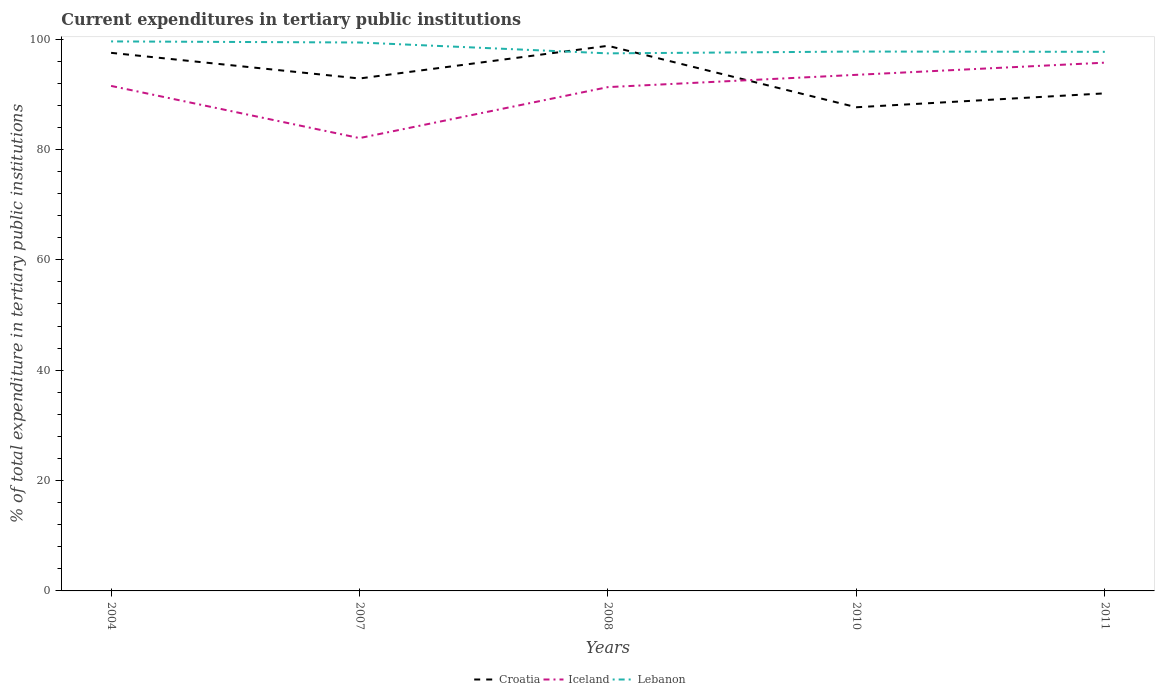Is the number of lines equal to the number of legend labels?
Your answer should be compact. Yes. Across all years, what is the maximum current expenditures in tertiary public institutions in Lebanon?
Offer a terse response. 97.41. What is the total current expenditures in tertiary public institutions in Lebanon in the graph?
Provide a succinct answer. 0.2. What is the difference between the highest and the second highest current expenditures in tertiary public institutions in Iceland?
Offer a terse response. 13.67. Is the current expenditures in tertiary public institutions in Lebanon strictly greater than the current expenditures in tertiary public institutions in Iceland over the years?
Your answer should be very brief. No. How many lines are there?
Provide a short and direct response. 3. What is the difference between two consecutive major ticks on the Y-axis?
Offer a very short reply. 20. Does the graph contain grids?
Make the answer very short. No. How many legend labels are there?
Provide a short and direct response. 3. What is the title of the graph?
Provide a succinct answer. Current expenditures in tertiary public institutions. Does "Spain" appear as one of the legend labels in the graph?
Make the answer very short. No. What is the label or title of the X-axis?
Ensure brevity in your answer.  Years. What is the label or title of the Y-axis?
Your response must be concise. % of total expenditure in tertiary public institutions. What is the % of total expenditure in tertiary public institutions of Croatia in 2004?
Your answer should be compact. 97.5. What is the % of total expenditure in tertiary public institutions of Iceland in 2004?
Keep it short and to the point. 91.51. What is the % of total expenditure in tertiary public institutions in Lebanon in 2004?
Make the answer very short. 99.57. What is the % of total expenditure in tertiary public institutions in Croatia in 2007?
Ensure brevity in your answer.  92.85. What is the % of total expenditure in tertiary public institutions of Iceland in 2007?
Give a very brief answer. 82.05. What is the % of total expenditure in tertiary public institutions in Lebanon in 2007?
Provide a succinct answer. 99.38. What is the % of total expenditure in tertiary public institutions in Croatia in 2008?
Keep it short and to the point. 98.78. What is the % of total expenditure in tertiary public institutions in Iceland in 2008?
Offer a terse response. 91.29. What is the % of total expenditure in tertiary public institutions in Lebanon in 2008?
Keep it short and to the point. 97.41. What is the % of total expenditure in tertiary public institutions of Croatia in 2010?
Make the answer very short. 87.64. What is the % of total expenditure in tertiary public institutions in Iceland in 2010?
Make the answer very short. 93.52. What is the % of total expenditure in tertiary public institutions in Lebanon in 2010?
Your answer should be very brief. 97.74. What is the % of total expenditure in tertiary public institutions in Croatia in 2011?
Your answer should be very brief. 90.16. What is the % of total expenditure in tertiary public institutions in Iceland in 2011?
Your answer should be compact. 95.72. What is the % of total expenditure in tertiary public institutions in Lebanon in 2011?
Your answer should be very brief. 97.69. Across all years, what is the maximum % of total expenditure in tertiary public institutions in Croatia?
Ensure brevity in your answer.  98.78. Across all years, what is the maximum % of total expenditure in tertiary public institutions of Iceland?
Keep it short and to the point. 95.72. Across all years, what is the maximum % of total expenditure in tertiary public institutions of Lebanon?
Keep it short and to the point. 99.57. Across all years, what is the minimum % of total expenditure in tertiary public institutions in Croatia?
Keep it short and to the point. 87.64. Across all years, what is the minimum % of total expenditure in tertiary public institutions of Iceland?
Make the answer very short. 82.05. Across all years, what is the minimum % of total expenditure in tertiary public institutions in Lebanon?
Your answer should be compact. 97.41. What is the total % of total expenditure in tertiary public institutions in Croatia in the graph?
Ensure brevity in your answer.  466.94. What is the total % of total expenditure in tertiary public institutions in Iceland in the graph?
Provide a short and direct response. 454.09. What is the total % of total expenditure in tertiary public institutions in Lebanon in the graph?
Offer a very short reply. 491.78. What is the difference between the % of total expenditure in tertiary public institutions in Croatia in 2004 and that in 2007?
Your response must be concise. 4.65. What is the difference between the % of total expenditure in tertiary public institutions of Iceland in 2004 and that in 2007?
Provide a succinct answer. 9.46. What is the difference between the % of total expenditure in tertiary public institutions of Lebanon in 2004 and that in 2007?
Offer a terse response. 0.2. What is the difference between the % of total expenditure in tertiary public institutions in Croatia in 2004 and that in 2008?
Offer a terse response. -1.27. What is the difference between the % of total expenditure in tertiary public institutions in Iceland in 2004 and that in 2008?
Make the answer very short. 0.22. What is the difference between the % of total expenditure in tertiary public institutions in Lebanon in 2004 and that in 2008?
Keep it short and to the point. 2.17. What is the difference between the % of total expenditure in tertiary public institutions in Croatia in 2004 and that in 2010?
Provide a succinct answer. 9.86. What is the difference between the % of total expenditure in tertiary public institutions in Iceland in 2004 and that in 2010?
Provide a succinct answer. -2.01. What is the difference between the % of total expenditure in tertiary public institutions in Lebanon in 2004 and that in 2010?
Make the answer very short. 1.84. What is the difference between the % of total expenditure in tertiary public institutions of Croatia in 2004 and that in 2011?
Keep it short and to the point. 7.34. What is the difference between the % of total expenditure in tertiary public institutions of Iceland in 2004 and that in 2011?
Provide a succinct answer. -4.21. What is the difference between the % of total expenditure in tertiary public institutions of Lebanon in 2004 and that in 2011?
Give a very brief answer. 1.89. What is the difference between the % of total expenditure in tertiary public institutions of Croatia in 2007 and that in 2008?
Make the answer very short. -5.92. What is the difference between the % of total expenditure in tertiary public institutions in Iceland in 2007 and that in 2008?
Offer a terse response. -9.24. What is the difference between the % of total expenditure in tertiary public institutions in Lebanon in 2007 and that in 2008?
Ensure brevity in your answer.  1.97. What is the difference between the % of total expenditure in tertiary public institutions of Croatia in 2007 and that in 2010?
Provide a short and direct response. 5.21. What is the difference between the % of total expenditure in tertiary public institutions of Iceland in 2007 and that in 2010?
Your answer should be very brief. -11.47. What is the difference between the % of total expenditure in tertiary public institutions of Lebanon in 2007 and that in 2010?
Ensure brevity in your answer.  1.64. What is the difference between the % of total expenditure in tertiary public institutions of Croatia in 2007 and that in 2011?
Keep it short and to the point. 2.69. What is the difference between the % of total expenditure in tertiary public institutions of Iceland in 2007 and that in 2011?
Provide a succinct answer. -13.67. What is the difference between the % of total expenditure in tertiary public institutions in Lebanon in 2007 and that in 2011?
Offer a terse response. 1.69. What is the difference between the % of total expenditure in tertiary public institutions in Croatia in 2008 and that in 2010?
Provide a succinct answer. 11.13. What is the difference between the % of total expenditure in tertiary public institutions of Iceland in 2008 and that in 2010?
Ensure brevity in your answer.  -2.22. What is the difference between the % of total expenditure in tertiary public institutions of Lebanon in 2008 and that in 2010?
Ensure brevity in your answer.  -0.33. What is the difference between the % of total expenditure in tertiary public institutions in Croatia in 2008 and that in 2011?
Keep it short and to the point. 8.62. What is the difference between the % of total expenditure in tertiary public institutions of Iceland in 2008 and that in 2011?
Give a very brief answer. -4.43. What is the difference between the % of total expenditure in tertiary public institutions of Lebanon in 2008 and that in 2011?
Your answer should be very brief. -0.28. What is the difference between the % of total expenditure in tertiary public institutions in Croatia in 2010 and that in 2011?
Your answer should be very brief. -2.52. What is the difference between the % of total expenditure in tertiary public institutions of Iceland in 2010 and that in 2011?
Your answer should be very brief. -2.21. What is the difference between the % of total expenditure in tertiary public institutions of Lebanon in 2010 and that in 2011?
Keep it short and to the point. 0.05. What is the difference between the % of total expenditure in tertiary public institutions in Croatia in 2004 and the % of total expenditure in tertiary public institutions in Iceland in 2007?
Offer a very short reply. 15.45. What is the difference between the % of total expenditure in tertiary public institutions in Croatia in 2004 and the % of total expenditure in tertiary public institutions in Lebanon in 2007?
Provide a short and direct response. -1.87. What is the difference between the % of total expenditure in tertiary public institutions in Iceland in 2004 and the % of total expenditure in tertiary public institutions in Lebanon in 2007?
Provide a succinct answer. -7.87. What is the difference between the % of total expenditure in tertiary public institutions of Croatia in 2004 and the % of total expenditure in tertiary public institutions of Iceland in 2008?
Provide a succinct answer. 6.21. What is the difference between the % of total expenditure in tertiary public institutions of Croatia in 2004 and the % of total expenditure in tertiary public institutions of Lebanon in 2008?
Keep it short and to the point. 0.09. What is the difference between the % of total expenditure in tertiary public institutions in Iceland in 2004 and the % of total expenditure in tertiary public institutions in Lebanon in 2008?
Make the answer very short. -5.9. What is the difference between the % of total expenditure in tertiary public institutions in Croatia in 2004 and the % of total expenditure in tertiary public institutions in Iceland in 2010?
Your answer should be compact. 3.99. What is the difference between the % of total expenditure in tertiary public institutions of Croatia in 2004 and the % of total expenditure in tertiary public institutions of Lebanon in 2010?
Provide a succinct answer. -0.23. What is the difference between the % of total expenditure in tertiary public institutions in Iceland in 2004 and the % of total expenditure in tertiary public institutions in Lebanon in 2010?
Keep it short and to the point. -6.23. What is the difference between the % of total expenditure in tertiary public institutions in Croatia in 2004 and the % of total expenditure in tertiary public institutions in Iceland in 2011?
Provide a succinct answer. 1.78. What is the difference between the % of total expenditure in tertiary public institutions in Croatia in 2004 and the % of total expenditure in tertiary public institutions in Lebanon in 2011?
Your answer should be compact. -0.18. What is the difference between the % of total expenditure in tertiary public institutions in Iceland in 2004 and the % of total expenditure in tertiary public institutions in Lebanon in 2011?
Your answer should be very brief. -6.18. What is the difference between the % of total expenditure in tertiary public institutions of Croatia in 2007 and the % of total expenditure in tertiary public institutions of Iceland in 2008?
Ensure brevity in your answer.  1.56. What is the difference between the % of total expenditure in tertiary public institutions of Croatia in 2007 and the % of total expenditure in tertiary public institutions of Lebanon in 2008?
Make the answer very short. -4.55. What is the difference between the % of total expenditure in tertiary public institutions of Iceland in 2007 and the % of total expenditure in tertiary public institutions of Lebanon in 2008?
Provide a succinct answer. -15.36. What is the difference between the % of total expenditure in tertiary public institutions in Croatia in 2007 and the % of total expenditure in tertiary public institutions in Iceland in 2010?
Your answer should be very brief. -0.66. What is the difference between the % of total expenditure in tertiary public institutions in Croatia in 2007 and the % of total expenditure in tertiary public institutions in Lebanon in 2010?
Keep it short and to the point. -4.88. What is the difference between the % of total expenditure in tertiary public institutions of Iceland in 2007 and the % of total expenditure in tertiary public institutions of Lebanon in 2010?
Offer a very short reply. -15.68. What is the difference between the % of total expenditure in tertiary public institutions of Croatia in 2007 and the % of total expenditure in tertiary public institutions of Iceland in 2011?
Your response must be concise. -2.87. What is the difference between the % of total expenditure in tertiary public institutions in Croatia in 2007 and the % of total expenditure in tertiary public institutions in Lebanon in 2011?
Offer a terse response. -4.83. What is the difference between the % of total expenditure in tertiary public institutions in Iceland in 2007 and the % of total expenditure in tertiary public institutions in Lebanon in 2011?
Make the answer very short. -15.63. What is the difference between the % of total expenditure in tertiary public institutions of Croatia in 2008 and the % of total expenditure in tertiary public institutions of Iceland in 2010?
Your answer should be compact. 5.26. What is the difference between the % of total expenditure in tertiary public institutions in Croatia in 2008 and the % of total expenditure in tertiary public institutions in Lebanon in 2010?
Your answer should be compact. 1.04. What is the difference between the % of total expenditure in tertiary public institutions in Iceland in 2008 and the % of total expenditure in tertiary public institutions in Lebanon in 2010?
Your answer should be very brief. -6.44. What is the difference between the % of total expenditure in tertiary public institutions in Croatia in 2008 and the % of total expenditure in tertiary public institutions in Iceland in 2011?
Your answer should be very brief. 3.05. What is the difference between the % of total expenditure in tertiary public institutions of Croatia in 2008 and the % of total expenditure in tertiary public institutions of Lebanon in 2011?
Offer a very short reply. 1.09. What is the difference between the % of total expenditure in tertiary public institutions of Iceland in 2008 and the % of total expenditure in tertiary public institutions of Lebanon in 2011?
Keep it short and to the point. -6.39. What is the difference between the % of total expenditure in tertiary public institutions in Croatia in 2010 and the % of total expenditure in tertiary public institutions in Iceland in 2011?
Give a very brief answer. -8.08. What is the difference between the % of total expenditure in tertiary public institutions of Croatia in 2010 and the % of total expenditure in tertiary public institutions of Lebanon in 2011?
Provide a short and direct response. -10.04. What is the difference between the % of total expenditure in tertiary public institutions of Iceland in 2010 and the % of total expenditure in tertiary public institutions of Lebanon in 2011?
Give a very brief answer. -4.17. What is the average % of total expenditure in tertiary public institutions in Croatia per year?
Your response must be concise. 93.39. What is the average % of total expenditure in tertiary public institutions in Iceland per year?
Provide a succinct answer. 90.82. What is the average % of total expenditure in tertiary public institutions of Lebanon per year?
Offer a very short reply. 98.36. In the year 2004, what is the difference between the % of total expenditure in tertiary public institutions in Croatia and % of total expenditure in tertiary public institutions in Iceland?
Give a very brief answer. 5.99. In the year 2004, what is the difference between the % of total expenditure in tertiary public institutions in Croatia and % of total expenditure in tertiary public institutions in Lebanon?
Offer a terse response. -2.07. In the year 2004, what is the difference between the % of total expenditure in tertiary public institutions in Iceland and % of total expenditure in tertiary public institutions in Lebanon?
Give a very brief answer. -8.06. In the year 2007, what is the difference between the % of total expenditure in tertiary public institutions in Croatia and % of total expenditure in tertiary public institutions in Iceland?
Make the answer very short. 10.8. In the year 2007, what is the difference between the % of total expenditure in tertiary public institutions in Croatia and % of total expenditure in tertiary public institutions in Lebanon?
Provide a succinct answer. -6.52. In the year 2007, what is the difference between the % of total expenditure in tertiary public institutions in Iceland and % of total expenditure in tertiary public institutions in Lebanon?
Your answer should be very brief. -17.32. In the year 2008, what is the difference between the % of total expenditure in tertiary public institutions in Croatia and % of total expenditure in tertiary public institutions in Iceland?
Ensure brevity in your answer.  7.48. In the year 2008, what is the difference between the % of total expenditure in tertiary public institutions in Croatia and % of total expenditure in tertiary public institutions in Lebanon?
Give a very brief answer. 1.37. In the year 2008, what is the difference between the % of total expenditure in tertiary public institutions of Iceland and % of total expenditure in tertiary public institutions of Lebanon?
Provide a short and direct response. -6.12. In the year 2010, what is the difference between the % of total expenditure in tertiary public institutions in Croatia and % of total expenditure in tertiary public institutions in Iceland?
Offer a very short reply. -5.87. In the year 2010, what is the difference between the % of total expenditure in tertiary public institutions in Croatia and % of total expenditure in tertiary public institutions in Lebanon?
Provide a succinct answer. -10.09. In the year 2010, what is the difference between the % of total expenditure in tertiary public institutions in Iceland and % of total expenditure in tertiary public institutions in Lebanon?
Make the answer very short. -4.22. In the year 2011, what is the difference between the % of total expenditure in tertiary public institutions in Croatia and % of total expenditure in tertiary public institutions in Iceland?
Your answer should be very brief. -5.56. In the year 2011, what is the difference between the % of total expenditure in tertiary public institutions in Croatia and % of total expenditure in tertiary public institutions in Lebanon?
Provide a short and direct response. -7.52. In the year 2011, what is the difference between the % of total expenditure in tertiary public institutions in Iceland and % of total expenditure in tertiary public institutions in Lebanon?
Make the answer very short. -1.96. What is the ratio of the % of total expenditure in tertiary public institutions of Croatia in 2004 to that in 2007?
Your answer should be compact. 1.05. What is the ratio of the % of total expenditure in tertiary public institutions of Iceland in 2004 to that in 2007?
Keep it short and to the point. 1.12. What is the ratio of the % of total expenditure in tertiary public institutions in Croatia in 2004 to that in 2008?
Provide a succinct answer. 0.99. What is the ratio of the % of total expenditure in tertiary public institutions in Lebanon in 2004 to that in 2008?
Your answer should be very brief. 1.02. What is the ratio of the % of total expenditure in tertiary public institutions in Croatia in 2004 to that in 2010?
Give a very brief answer. 1.11. What is the ratio of the % of total expenditure in tertiary public institutions of Iceland in 2004 to that in 2010?
Provide a succinct answer. 0.98. What is the ratio of the % of total expenditure in tertiary public institutions of Lebanon in 2004 to that in 2010?
Offer a terse response. 1.02. What is the ratio of the % of total expenditure in tertiary public institutions in Croatia in 2004 to that in 2011?
Provide a short and direct response. 1.08. What is the ratio of the % of total expenditure in tertiary public institutions of Iceland in 2004 to that in 2011?
Ensure brevity in your answer.  0.96. What is the ratio of the % of total expenditure in tertiary public institutions of Lebanon in 2004 to that in 2011?
Give a very brief answer. 1.02. What is the ratio of the % of total expenditure in tertiary public institutions of Iceland in 2007 to that in 2008?
Offer a terse response. 0.9. What is the ratio of the % of total expenditure in tertiary public institutions in Lebanon in 2007 to that in 2008?
Offer a terse response. 1.02. What is the ratio of the % of total expenditure in tertiary public institutions of Croatia in 2007 to that in 2010?
Make the answer very short. 1.06. What is the ratio of the % of total expenditure in tertiary public institutions of Iceland in 2007 to that in 2010?
Provide a short and direct response. 0.88. What is the ratio of the % of total expenditure in tertiary public institutions in Lebanon in 2007 to that in 2010?
Keep it short and to the point. 1.02. What is the ratio of the % of total expenditure in tertiary public institutions in Croatia in 2007 to that in 2011?
Your answer should be very brief. 1.03. What is the ratio of the % of total expenditure in tertiary public institutions in Iceland in 2007 to that in 2011?
Ensure brevity in your answer.  0.86. What is the ratio of the % of total expenditure in tertiary public institutions in Lebanon in 2007 to that in 2011?
Keep it short and to the point. 1.02. What is the ratio of the % of total expenditure in tertiary public institutions of Croatia in 2008 to that in 2010?
Ensure brevity in your answer.  1.13. What is the ratio of the % of total expenditure in tertiary public institutions of Iceland in 2008 to that in 2010?
Provide a succinct answer. 0.98. What is the ratio of the % of total expenditure in tertiary public institutions of Croatia in 2008 to that in 2011?
Provide a succinct answer. 1.1. What is the ratio of the % of total expenditure in tertiary public institutions of Iceland in 2008 to that in 2011?
Offer a terse response. 0.95. What is the ratio of the % of total expenditure in tertiary public institutions in Croatia in 2010 to that in 2011?
Keep it short and to the point. 0.97. What is the ratio of the % of total expenditure in tertiary public institutions of Lebanon in 2010 to that in 2011?
Your response must be concise. 1. What is the difference between the highest and the second highest % of total expenditure in tertiary public institutions in Croatia?
Your answer should be compact. 1.27. What is the difference between the highest and the second highest % of total expenditure in tertiary public institutions in Iceland?
Your answer should be very brief. 2.21. What is the difference between the highest and the second highest % of total expenditure in tertiary public institutions in Lebanon?
Ensure brevity in your answer.  0.2. What is the difference between the highest and the lowest % of total expenditure in tertiary public institutions of Croatia?
Offer a terse response. 11.13. What is the difference between the highest and the lowest % of total expenditure in tertiary public institutions in Iceland?
Offer a terse response. 13.67. What is the difference between the highest and the lowest % of total expenditure in tertiary public institutions of Lebanon?
Your answer should be very brief. 2.17. 